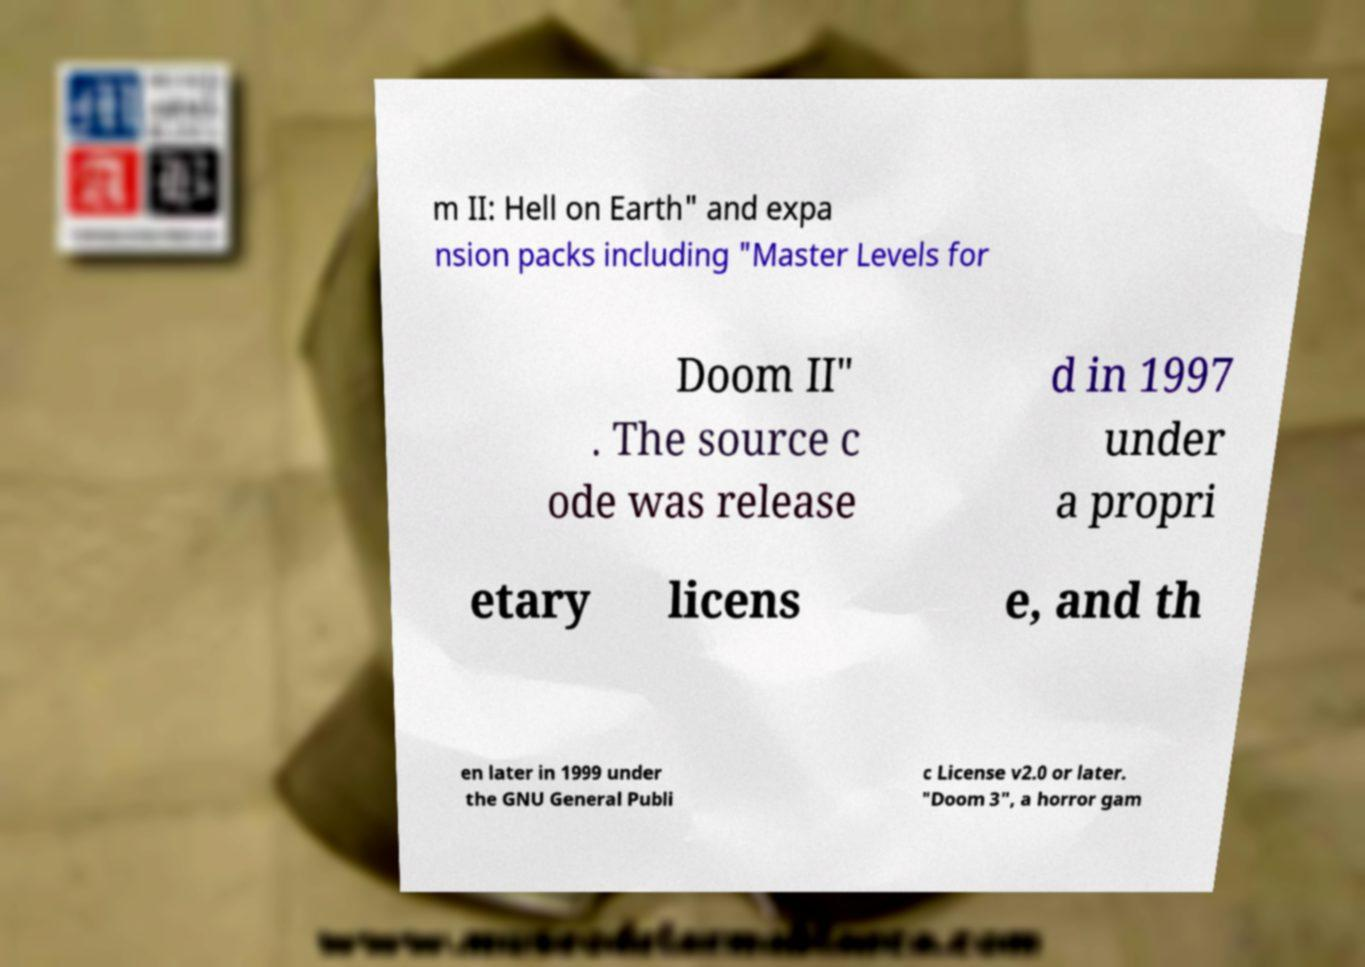What messages or text are displayed in this image? I need them in a readable, typed format. m II: Hell on Earth" and expa nsion packs including "Master Levels for Doom II" . The source c ode was release d in 1997 under a propri etary licens e, and th en later in 1999 under the GNU General Publi c License v2.0 or later. "Doom 3", a horror gam 